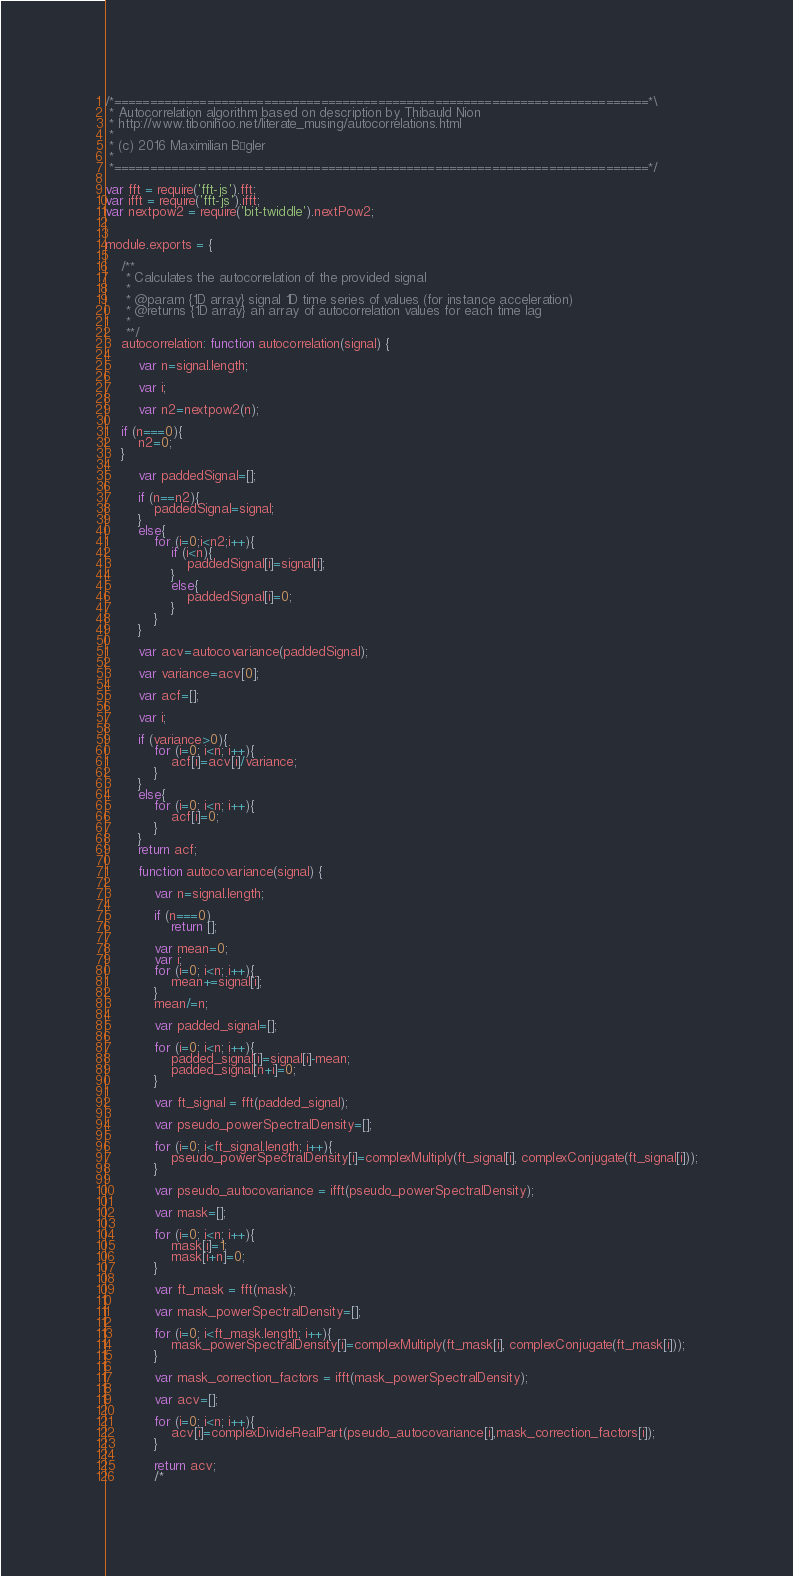<code> <loc_0><loc_0><loc_500><loc_500><_JavaScript_>/*===========================================================================*\
 * Autocorrelation algorithm based on description by Thibauld Nion
 * http://www.tibonihoo.net/literate_musing/autocorrelations.html
 *
 * (c) 2016 Maximilian Bügler
 *
 *===========================================================================*/

var fft = require('fft-js').fft;
var ifft = require('fft-js').ifft;
var nextpow2 = require('bit-twiddle').nextPow2;


module.exports = {
    
    /**
     * Calculates the autocorrelation of the provided signal
     *
     * @param {1D array} signal 1D time series of values (for instance acceleration)
     * @returns {1D array} an array of autocorrelation values for each time lag
     *
     **/
    autocorrelation: function autocorrelation(signal) {
        
        var n=signal.length;
        
        var i;
        
        var n2=nextpow2(n);

	if (n===0){
	    n2=0;
	}
        
        var paddedSignal=[];
        
        if (n==n2){
            paddedSignal=signal;
        }
        else{
            for (i=0;i<n2;i++){
                if (i<n){
                    paddedSignal[i]=signal[i];
                }
                else{
                    paddedSignal[i]=0;
                }
            }
        }

        var acv=autocovariance(paddedSignal);
        
        var variance=acv[0];
        
        var acf=[];
        
        var i;
        
        if (variance>0){
            for (i=0; i<n; i++){
                acf[i]=acv[i]/variance;    
            }
        }
        else{
            for (i=0; i<n; i++){
                acf[i]=0;    
            }            
        }
        return acf;
    
        function autocovariance(signal) {
            
            var n=signal.length;
            
            if (n===0)
                return [];
            
            var mean=0;
            var i;
            for (i=0; i<n; i++){
                mean+=signal[i];
            }
            mean/=n;
                      
            var padded_signal=[];
            
            for (i=0; i<n; i++){
                padded_signal[i]=signal[i]-mean;
                padded_signal[n+i]=0;
            }
                        
            var ft_signal = fft(padded_signal);
                       
            var pseudo_powerSpectralDensity=[];
            
            for (i=0; i<ft_signal.length; i++){
                pseudo_powerSpectralDensity[i]=complexMultiply(ft_signal[i], complexConjugate(ft_signal[i]));
            }
           
            var pseudo_autocovariance = ifft(pseudo_powerSpectralDensity);
    
            var mask=[];
            
            for (i=0; i<n; i++){
                mask[i]=1;
                mask[i+n]=0;
            }
            
            var ft_mask = fft(mask);
    
            var mask_powerSpectralDensity=[];
            
            for (i=0; i<ft_mask.length; i++){
                mask_powerSpectralDensity[i]=complexMultiply(ft_mask[i], complexConjugate(ft_mask[i]));
            }
            
            var mask_correction_factors = ifft(mask_powerSpectralDensity);
    
            var acv=[];
            
            for (i=0; i<n; i++){
                acv[i]=complexDivideRealPart(pseudo_autocovariance[i],mask_correction_factors[i]);
            }    
            
            return acv;
            /*</code> 